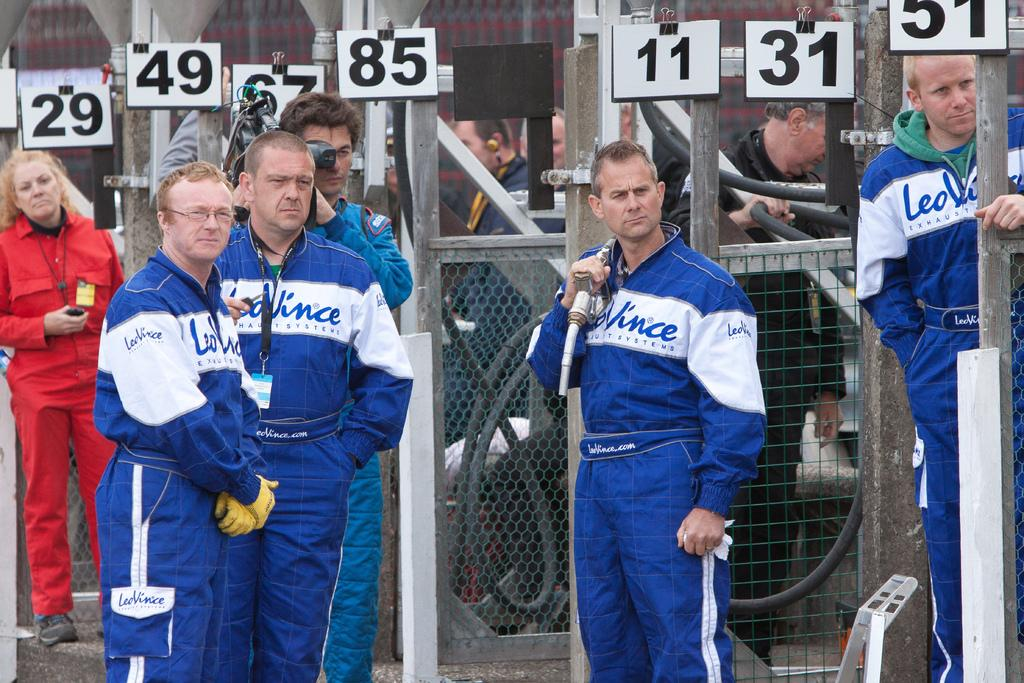<image>
Share a concise interpretation of the image provided. some people in blue standing around and a sign that has 49 on it 